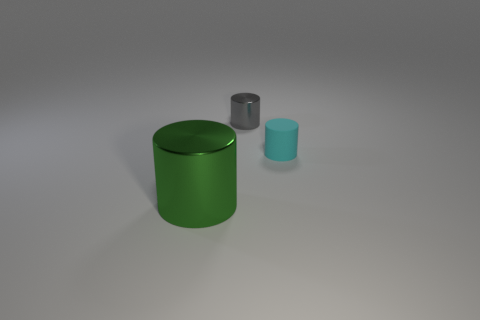Can you describe the lighting source in the image? The lighting source in the image appears to be diffused, probably coming from above and slightly to the right of the scene, as indicated by the gentle shadows under the objects. 